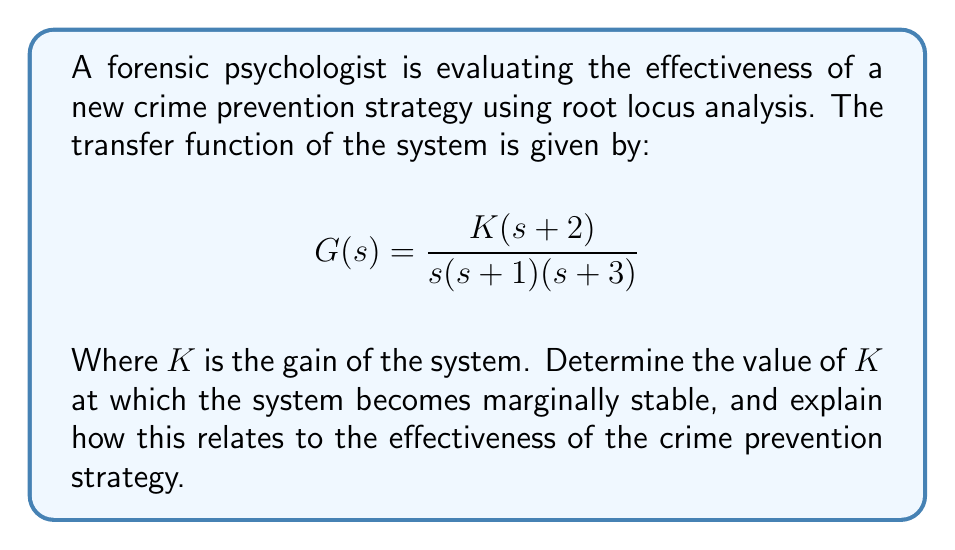Could you help me with this problem? To evaluate the effectiveness of the crime prevention strategy using root locus analysis, we need to find the value of $K$ at which the system becomes marginally stable. This occurs when the root locus crosses the imaginary axis.

Step 1: Write the characteristic equation
The characteristic equation is 1 + KG(s) = 0
$$1 + \frac{K(s+2)}{s(s+1)(s+3)} = 0$$

Step 2: Substitute s = jω (for marginal stability)
$$1 + \frac{K(j\omega+2)}{j\omega(j\omega+1)(j\omega+3)} = 0$$

Step 3: Separate real and imaginary parts
Real part:
$$1 + \frac{K(2\omega^2-6)}{(\omega^2+9)(\omega^2+1)} = 0$$

Imaginary part:
$$\frac{K\omega(5-\omega^2)}{(\omega^2+9)(\omega^2+1)} = 0$$

Step 4: Solve the imaginary part for ω
The imaginary part is zero when ω = 0 or ω = √5

Step 5: Substitute ω = √5 into the real part and solve for K
$$1 + \frac{K(2(5)-6)}{((5)+9)((5)+1)} = 0$$
$$1 + \frac{4K}{14 \cdot 6} = 0$$
$$1 + \frac{K}{21} = 0$$
$$K = 21$$

The system becomes marginally stable when K = 21. This means that for K < 21, the system is stable, and for K > 21, the system becomes unstable.

In the context of crime prevention, this analysis suggests that the strategy's effectiveness (represented by K) has a critical threshold. Up to K = 21, increasing the intensity or resources of the prevention strategy (increasing K) improves its effectiveness. However, beyond this point, the strategy may become counterproductive or lead to unintended consequences, potentially causing instability in the crime prevention system.
Answer: The system becomes marginally stable when $K = 21$. This value represents the critical threshold for the crime prevention strategy's effectiveness. 